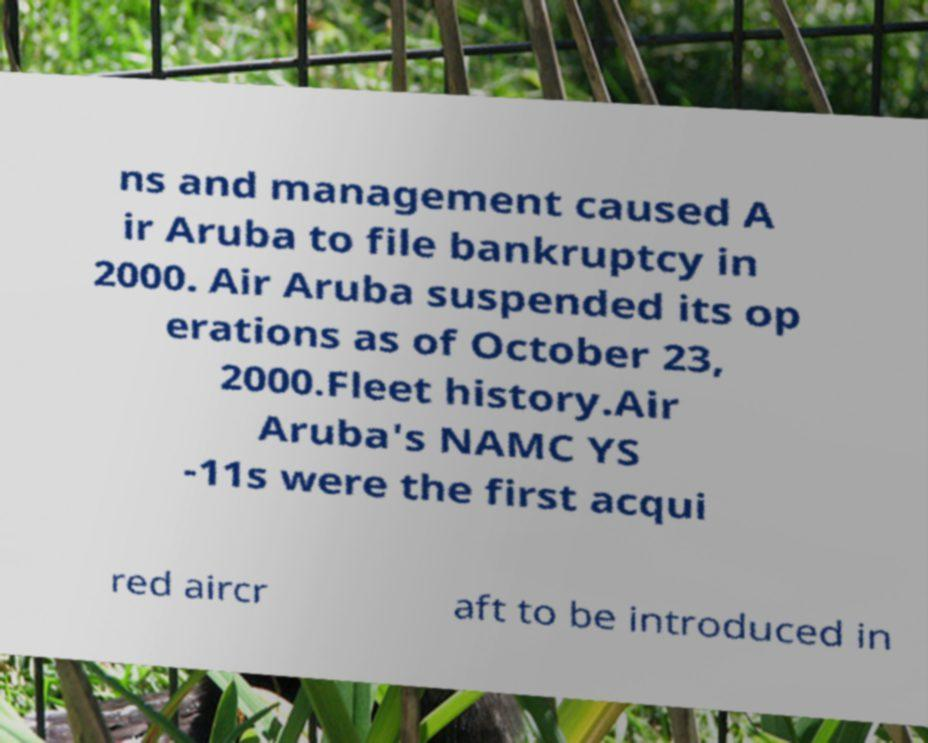Can you read and provide the text displayed in the image?This photo seems to have some interesting text. Can you extract and type it out for me? ns and management caused A ir Aruba to file bankruptcy in 2000. Air Aruba suspended its op erations as of October 23, 2000.Fleet history.Air Aruba's NAMC YS -11s were the first acqui red aircr aft to be introduced in 